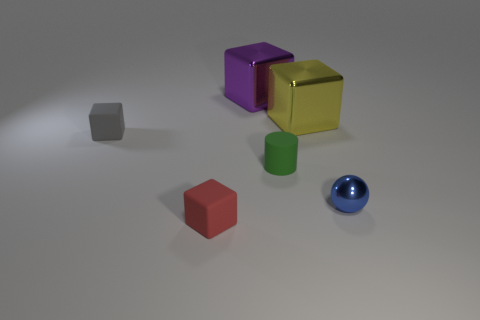There is a metallic thing that is in front of the small gray matte cube; is it the same size as the cube behind the yellow metallic thing?
Provide a succinct answer. No. How many cubes are either blue metal things or gray rubber things?
Your answer should be compact. 1. Is the material of the cube that is in front of the small shiny sphere the same as the large purple block?
Your response must be concise. No. What number of other things are the same size as the red rubber cube?
Offer a very short reply. 3. What number of small things are cylinders or purple shiny objects?
Offer a very short reply. 1. Is the number of tiny red cubes to the left of the yellow cube greater than the number of rubber objects on the left side of the purple thing?
Keep it short and to the point. No. Are there any other things that are the same color as the sphere?
Ensure brevity in your answer.  No. Are there more shiny objects to the right of the large yellow shiny cube than small blue matte cylinders?
Offer a very short reply. Yes. Is the size of the blue metallic ball the same as the green rubber thing?
Your response must be concise. Yes. What is the material of the yellow object that is the same shape as the gray object?
Offer a very short reply. Metal. 